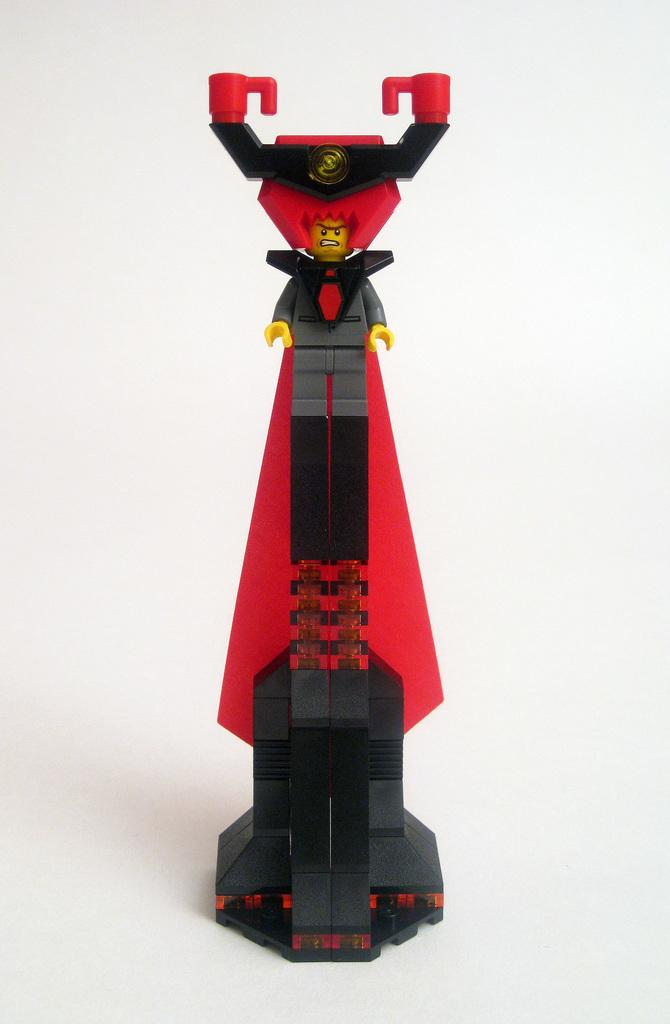What object can be seen in the image? There is a toy in the image. What colors are present on the toy? The toy has black, grey, yellow, and red colors. What is the color of the background in the image? The background of the image is white. What type of business is being conducted in the image? There is no indication of any business activity in the image; it features a toy with specific colors against a white background. Can you tell me how many lettuce leaves are present in the image? There are no lettuce leaves present in the image. 